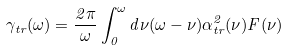<formula> <loc_0><loc_0><loc_500><loc_500>\gamma _ { t r } ( \omega ) = \frac { 2 \pi } { \omega } \int _ { 0 } ^ { \omega } d \nu ( \omega - \nu ) \alpha _ { t r } ^ { 2 } ( \nu ) F ( \nu )</formula> 